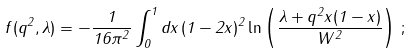Convert formula to latex. <formula><loc_0><loc_0><loc_500><loc_500>f ( q ^ { 2 } , \lambda ) = - \frac { 1 } { 1 6 \pi ^ { 2 } } \int _ { 0 } ^ { 1 } d x \, ( 1 - 2 x ) ^ { 2 } \ln \left ( \frac { \lambda + q ^ { 2 } x ( 1 - x ) } { W ^ { 2 } } \right ) \, ;</formula> 